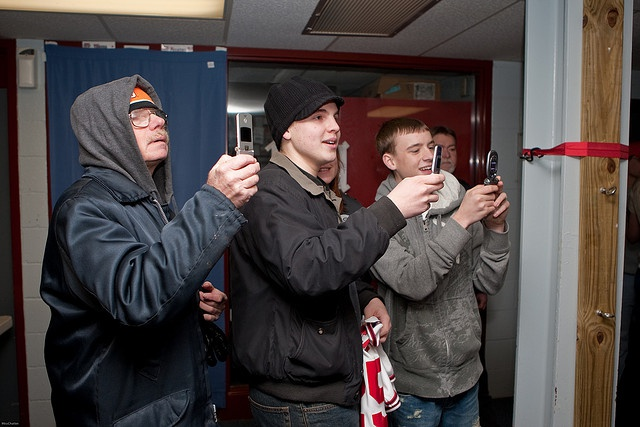Describe the objects in this image and their specific colors. I can see people in tan, black, gray, and darkblue tones, people in tan, black, gray, lightgray, and lightpink tones, people in tan, gray, black, and lightpink tones, people in tan, black, brown, and maroon tones, and people in tan, black, brown, and maroon tones in this image. 